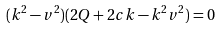<formula> <loc_0><loc_0><loc_500><loc_500>( k ^ { 2 } - v ^ { 2 } ) ( 2 Q + 2 c k - k ^ { 2 } v ^ { 2 } ) = 0</formula> 